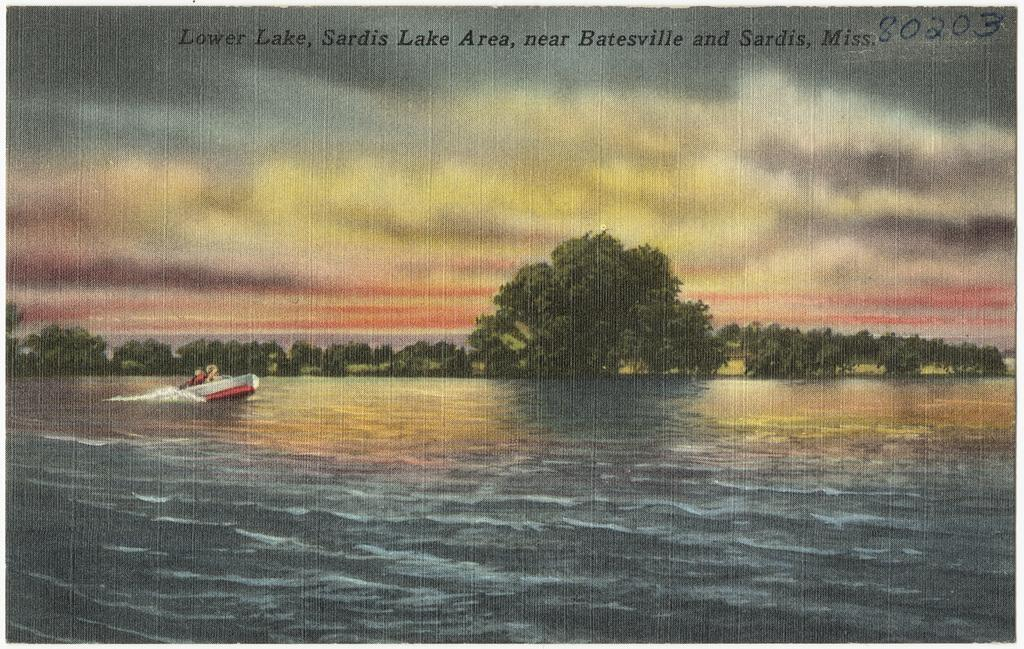What type of visual is the image? The image is a poster. What is depicted in the main image of the poster? There is a boat on the water in the poster. What other elements can be seen in the poster? There are trees and the sky is visible in the background of the poster. Is there any text on the poster? Yes, there is text at the top of the poster. What type of fact can be seen in the image? There is no fact present in the image; it is a poster featuring a boat on the water, trees, and text. Can you see the father of the person who created the poster in the image? There is no person or figure in the image that could be identified as the father of the poster's creator. 